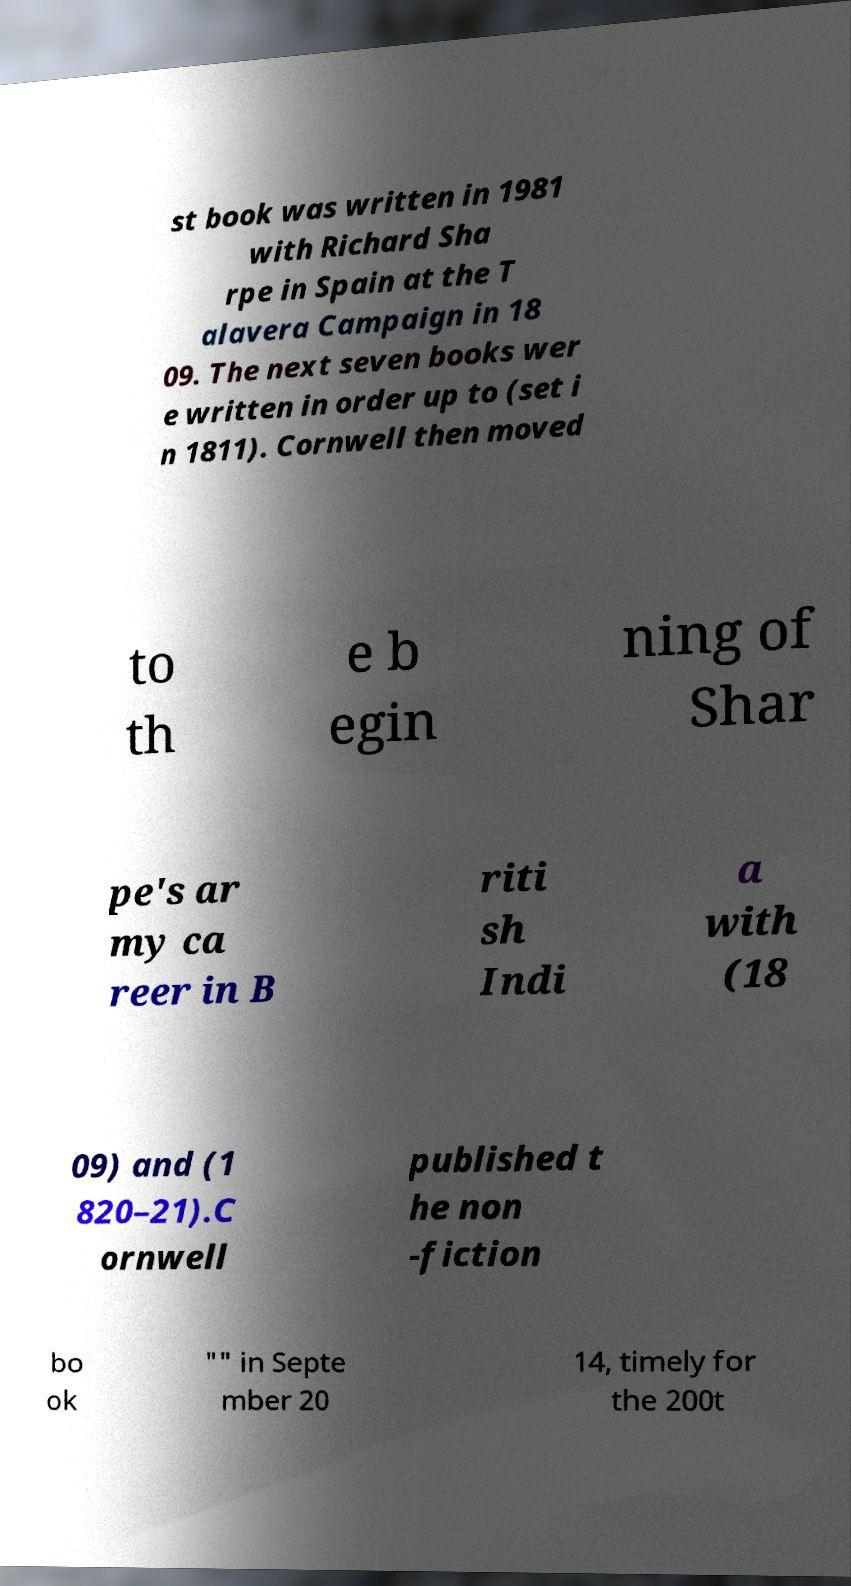I need the written content from this picture converted into text. Can you do that? st book was written in 1981 with Richard Sha rpe in Spain at the T alavera Campaign in 18 09. The next seven books wer e written in order up to (set i n 1811). Cornwell then moved to th e b egin ning of Shar pe's ar my ca reer in B riti sh Indi a with (18 09) and (1 820–21).C ornwell published t he non -fiction bo ok "" in Septe mber 20 14, timely for the 200t 